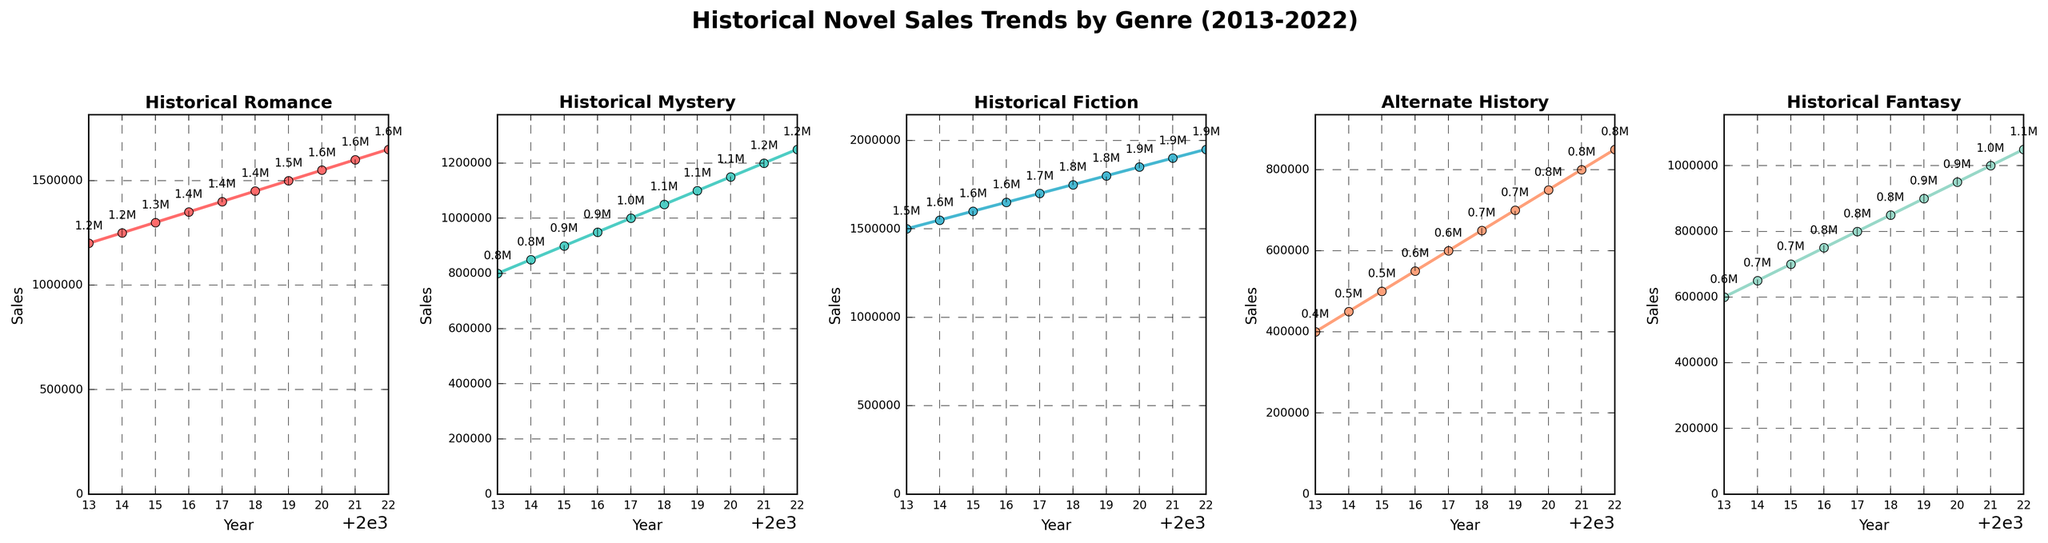What genre had the highest sales in 2022? To find this, look at the final data point for each genre's plot. Historical Fiction has the highest value at 1,950,000.
Answer: Historical Fiction Which genre showed the most consistent sales growth over the decade? Consistent growth means a steady upward trend without drops. By examining each plot, Historical Romance displays the most consistent and steady increase in sales.
Answer: Historical Romance How do the sales of Alternate History novels compare from 2013 to 2022? Evaluate the start and end points of the Alternate History sales line. In 2013, the sales were 400,000, while in 2022, they reached 850,000. Calculating the difference, we get 850,000 - 400,000 = 450,000. Therefore, sales increased by 450,000.
Answer: Increased by 450,000 By how much did Historical Mystery sales increase from 2014 to 2019? Find the sales values for 2014 and 2019. For Historical Mystery, the sales in 2014 were 850,000 and in 2019 were 1,100,000. The increase is 1,100,000 - 850,000 = 250,000.
Answer: 250,000 Which genre had the smallest increase in sales between 2013 and 2022? Compare the sales increase for each genre between 2013 and 2022. The differences are: Historical Romance (450,000), Historical Mystery (450,000), Historical Fiction (450,000), Alternate History (450,000), and Historical Fantasy (450,000). All increases are the same. Therefore, no genre had a smaller increase.
Answer: All increases are the same In what year did Historical Fantasy sales reach the 1 million mark? Find the point where Historical Fantasy sales reached 1,000,000. This occurs in 2021 with sales at 1,000,000.
Answer: 2021 Compare the sales trends of Historical Fiction and Alternate History. Which one had a steeper growth rate? A steeper growth rate means a larger increase over the same period. Historical Fiction went from 1,500,000 to 1,950,000 (an increase of 450,000), while Alternate History went from 400,000 to 850,000 (also an increase of 450,000). Relative to their initial values, both growth rates are equal.
Answer: Equal growth rate Which years showed the fastest growth in Historical Romance sales? To find this, identify where the slope of the line is steepest. Each year, Historical Romance sales increased by 50,000, showing a steady increase, i.e., no particular year shows faster growth compared to others.
Answer: All years had equal growth What is the average sales for Historical Romance over the decade? Add yearly sales values from 2013 to 2022 for Historical Romance, then divide by 10: (1,200,000 + 1,250,000 + 1,300,000 + 1,350,000 + 1,400,000 + 1,450,000 + 1,500,000 + 1,550,000 + 1,600,000 + 1,650,000) / 10 = 1,430,000.
Answer: 1,430,000 